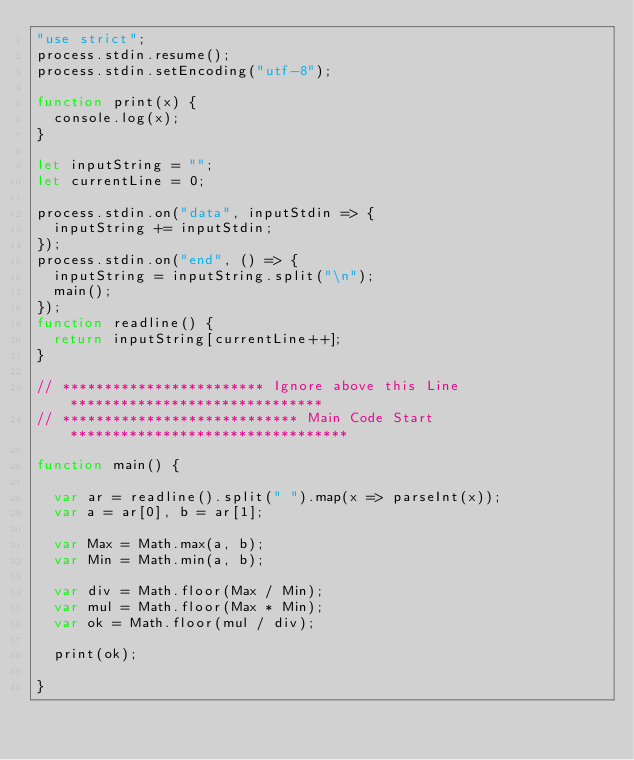Convert code to text. <code><loc_0><loc_0><loc_500><loc_500><_JavaScript_>"use strict";
process.stdin.resume();
process.stdin.setEncoding("utf-8");

function print(x) {
  console.log(x);
}

let inputString = "";
let currentLine = 0;

process.stdin.on("data", inputStdin => {
  inputString += inputStdin;
});
process.stdin.on("end", () => {
  inputString = inputString.split("\n");
  main();
});
function readline() {
  return inputString[currentLine++];
}

// ************************ Ignore above this Line ******************************
// **************************** Main Code Start *********************************

function main() {

  var ar = readline().split(" ").map(x => parseInt(x));
  var a = ar[0], b = ar[1];

  var Max = Math.max(a, b);
  var Min = Math.min(a, b);

  var div = Math.floor(Max / Min);
  var mul = Math.floor(Max * Min);
  var ok = Math.floor(mul / div);

  print(ok);
  
}
</code> 